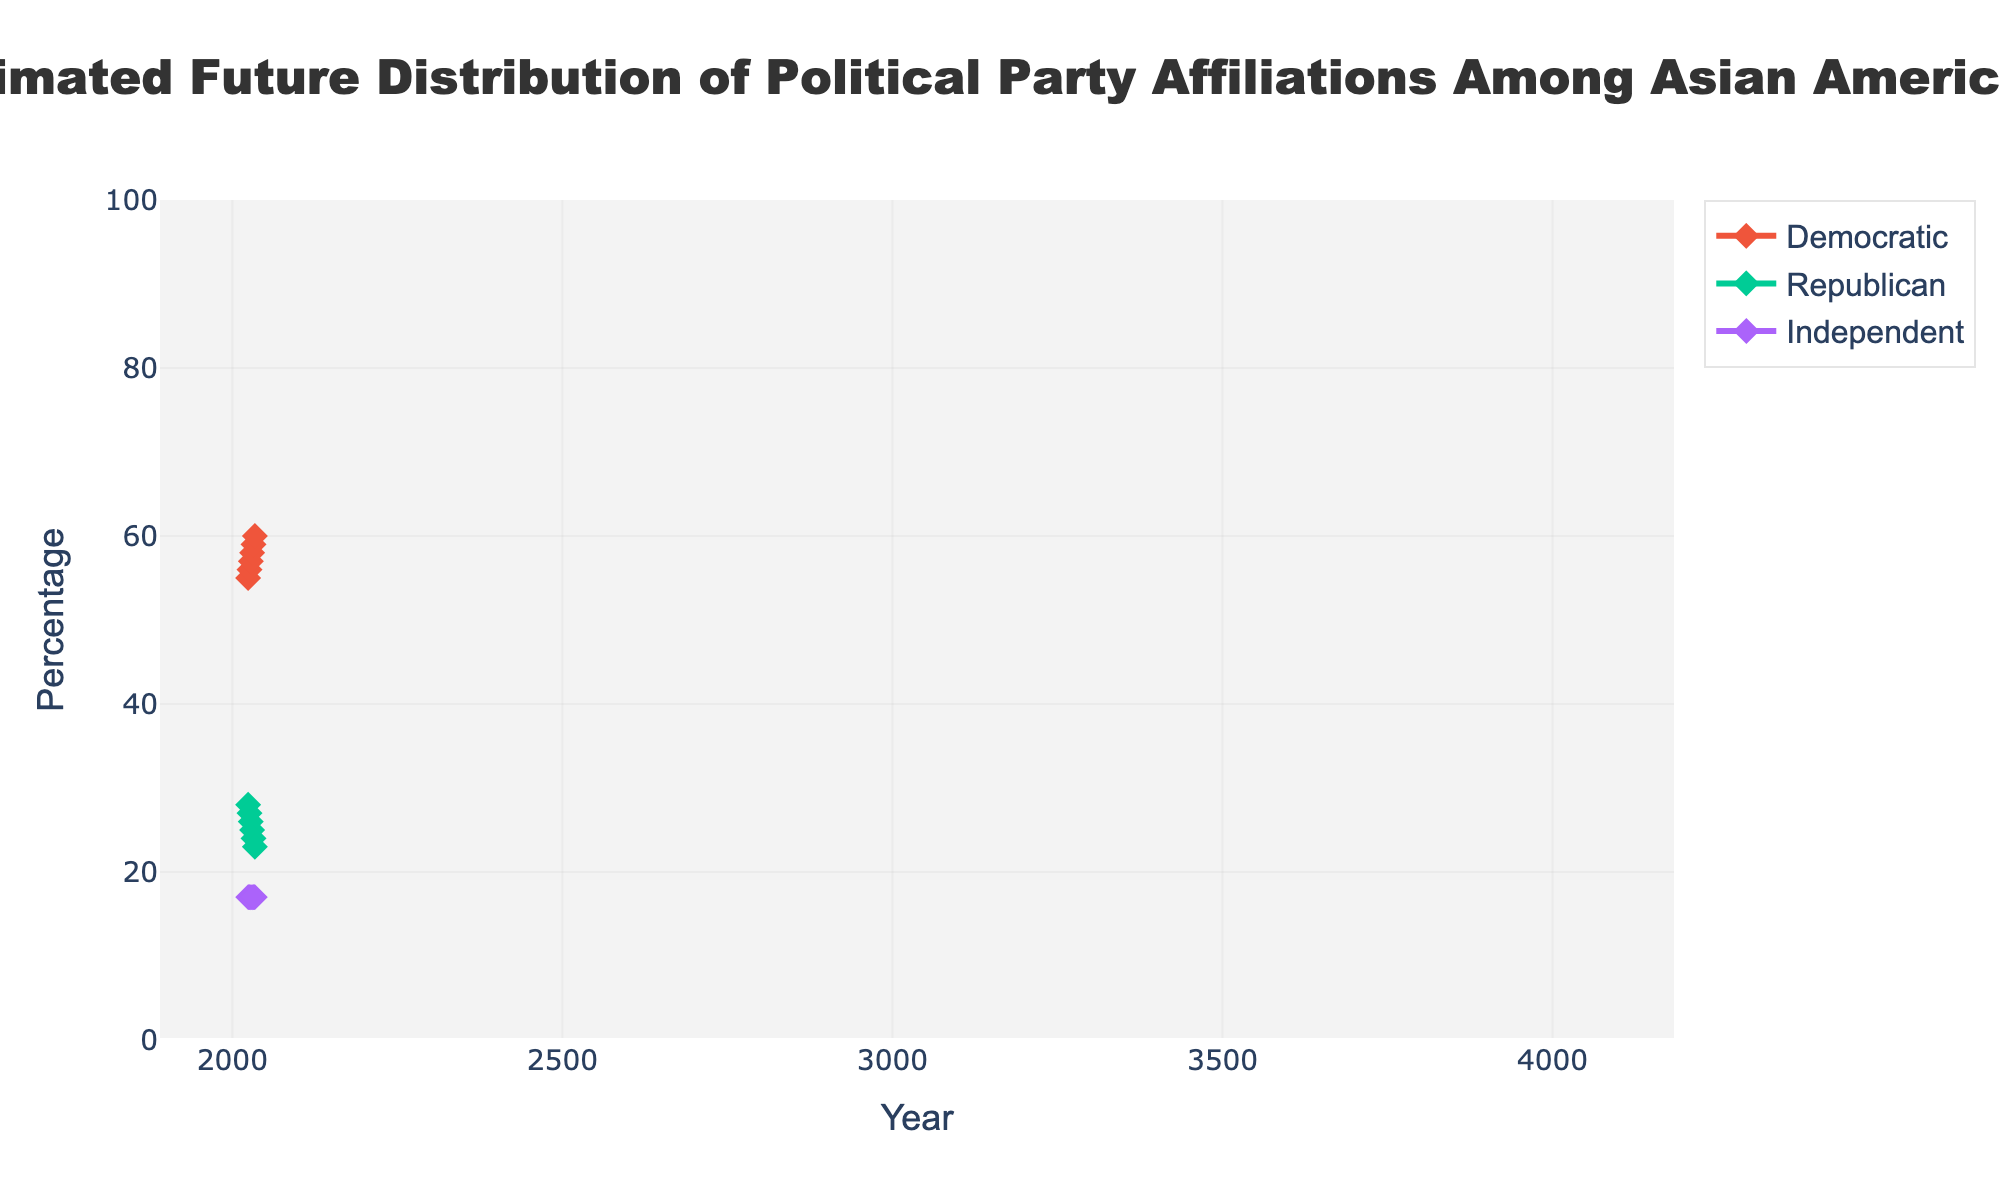What is the title of the chart? The title is the text appearing at the top of the chart. It is usually in a larger font and serves to describe what the chart is about.
Answer: Estimated Future Distribution of Political Party Affiliations Among Asian Americans What is the projected percentage of Asian Americans identifying as Democratic in 2034? Locate the line labeled "Democratic" and follow it to the year 2034 on the x-axis. The corresponding y-value will give the information.
Answer: 60% Between which years does the chart estimate a high uncertainty in political affiliations? Observe the width of the shaded fan area. The larger the width, the higher the uncertainty. Find the years where the fan widens noticeably.
Answer: 2024 to 2034 Comparing Democratic and Republican affiliations, which one is expected to increase over time? Observe the trend lines for both Democratic and Republican affiliations. Identify which line is trending upwards and which is trending downwards.
Answer: Democratic What is the range of estimated Democratic affiliations in 2028? Look for the high and low values of the fan chart at the year 2028. This range will be shown in the shaded area of the chart.
Answer: 48% to 66% How much does the Republican affiliation percentage change from 2024 to 2034? Find the values for Republican affiliation in 2024 and 2034, then calculate the difference.
Answer: -5% Which party affiliation remains constant over the projection period? Observe all lines for different party affiliations. Identify the one that does not change over the years.
Answer: Independent What is the projected difference in percentage between Democratic and Republican affiliations in 2030? Find the percentages for Democratic and Republican affiliations in the year 2030 and subtract the Republican percentage from the Democratic percentage.
Answer: 33% How often is data presented in the figure? Determine the frequency of the data points along the x-axis. Look at the interval between years.
Answer: Every 2 years 